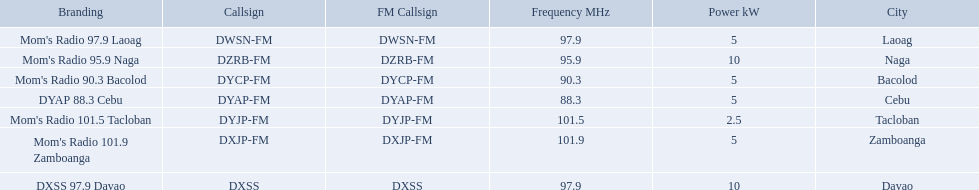What is the power capacity in kw for each team? 5 kW, 10 kW, 5 kW, 5 kW, 2.5 kW, 5 kW, 10 kW. Which is the lowest? 2.5 kW. What station has this amount of power? Mom's Radio 101.5 Tacloban. What are the frequencies for radios of dyap-fm? 97.9 MHz, 95.9 MHz, 90.3 MHz, 88.3 MHz, 101.5 MHz, 101.9 MHz, 97.9 MHz. What is the lowest frequency? 88.3 MHz. Which radio has this frequency? DYAP 88.3 Cebu. What are all of the frequencies? 97.9 MHz, 95.9 MHz, 90.3 MHz, 88.3 MHz, 101.5 MHz, 101.9 MHz, 97.9 MHz. Which of these frequencies is the lowest? 88.3 MHz. Which branding does this frequency belong to? DYAP 88.3 Cebu. What brandings have a power of 5 kw? Mom's Radio 97.9 Laoag, Mom's Radio 90.3 Bacolod, DYAP 88.3 Cebu, Mom's Radio 101.9 Zamboanga. Which of these has a call-sign beginning with dy? Mom's Radio 90.3 Bacolod, DYAP 88.3 Cebu. Which of those uses the lowest frequency? DYAP 88.3 Cebu. 